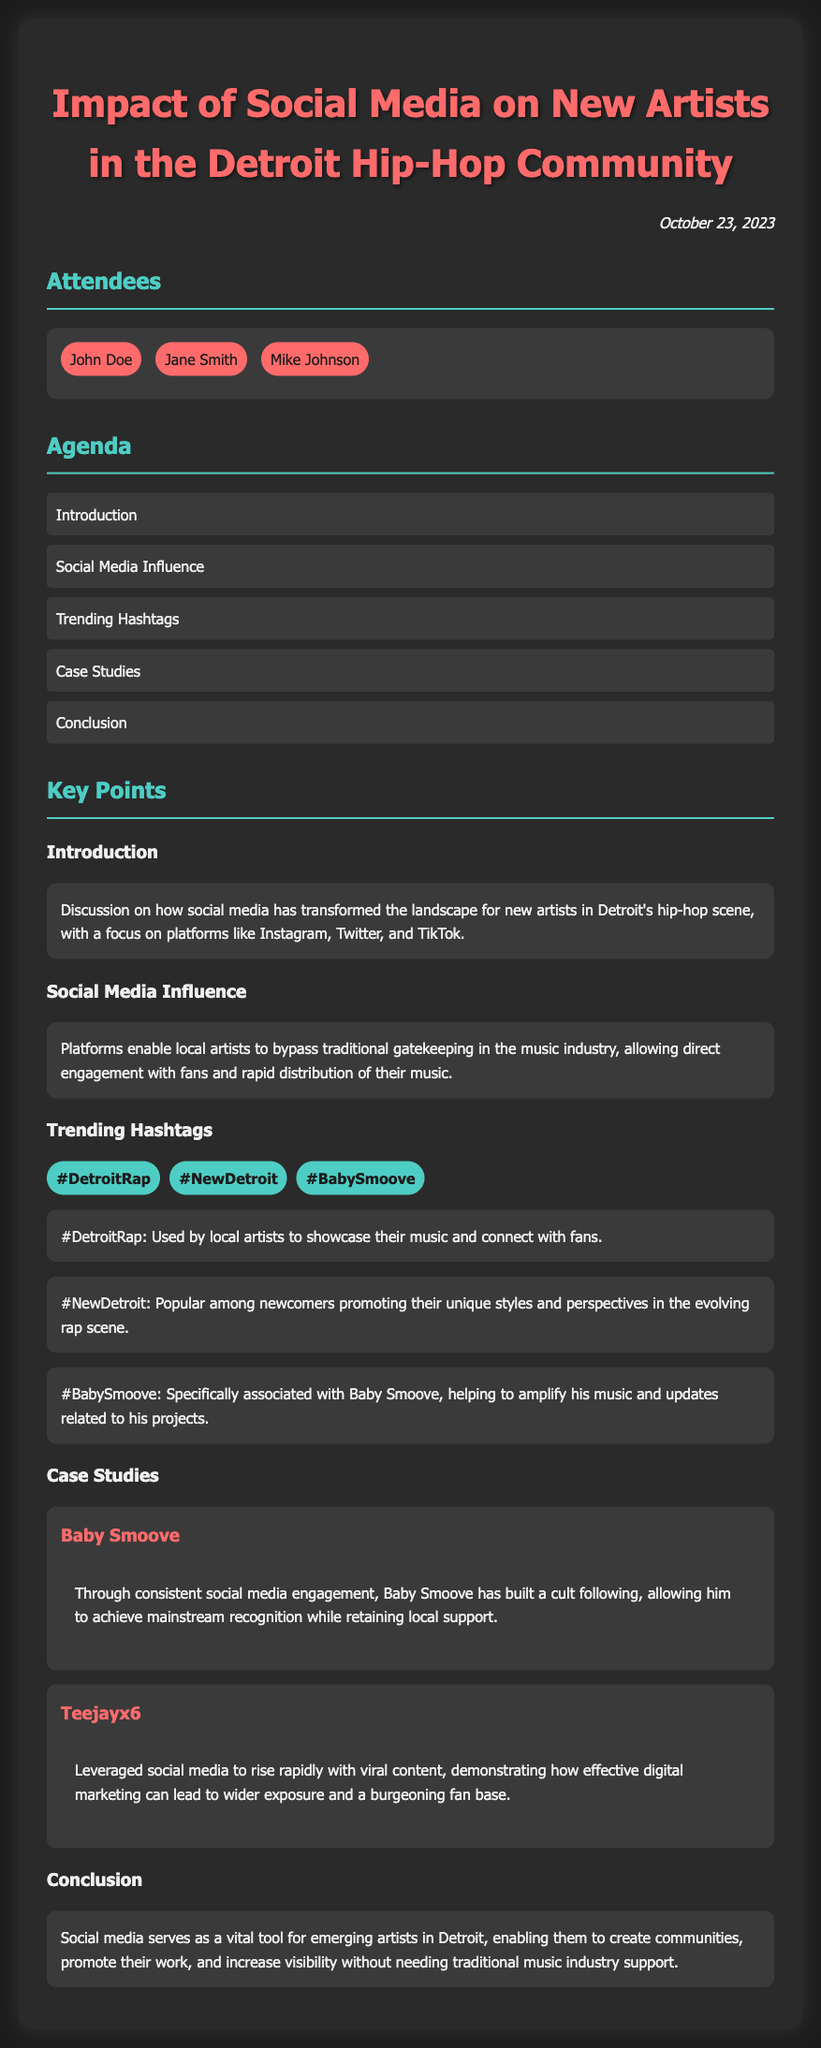What date was the meeting held? The date of the meeting is stated in the document as October 23, 2023.
Answer: October 23, 2023 Who is one of the attendees of the meeting? The attendees are listed in the document, including John Doe.
Answer: John Doe What is the main focus of the introduction section? The introduction discusses the transformation of the landscape for new artists in Detroit's hip-hop scene through social media.
Answer: Social media Which hashtag is associated specifically with Baby Smoove? The document mentions that #BabySmoove is specifically associated with him.
Answer: #BabySmoove How many case studies are presented in the document? The case studies section includes two detailed examples of artists.
Answer: Two What platform is noted for enabling direct engagement with fans? Social media platforms are highlighted for allowing direct engagement.
Answer: Social media platforms What color theme is used in the document for headings? The headings in the document utilize various shades of red and teal for emphasis.
Answer: Red and teal Which artist is mentioned in a case study as achieving mainstream recognition? Baby Smoove is noted for having built a cult following and achieving mainstream recognition.
Answer: Baby Smoove 